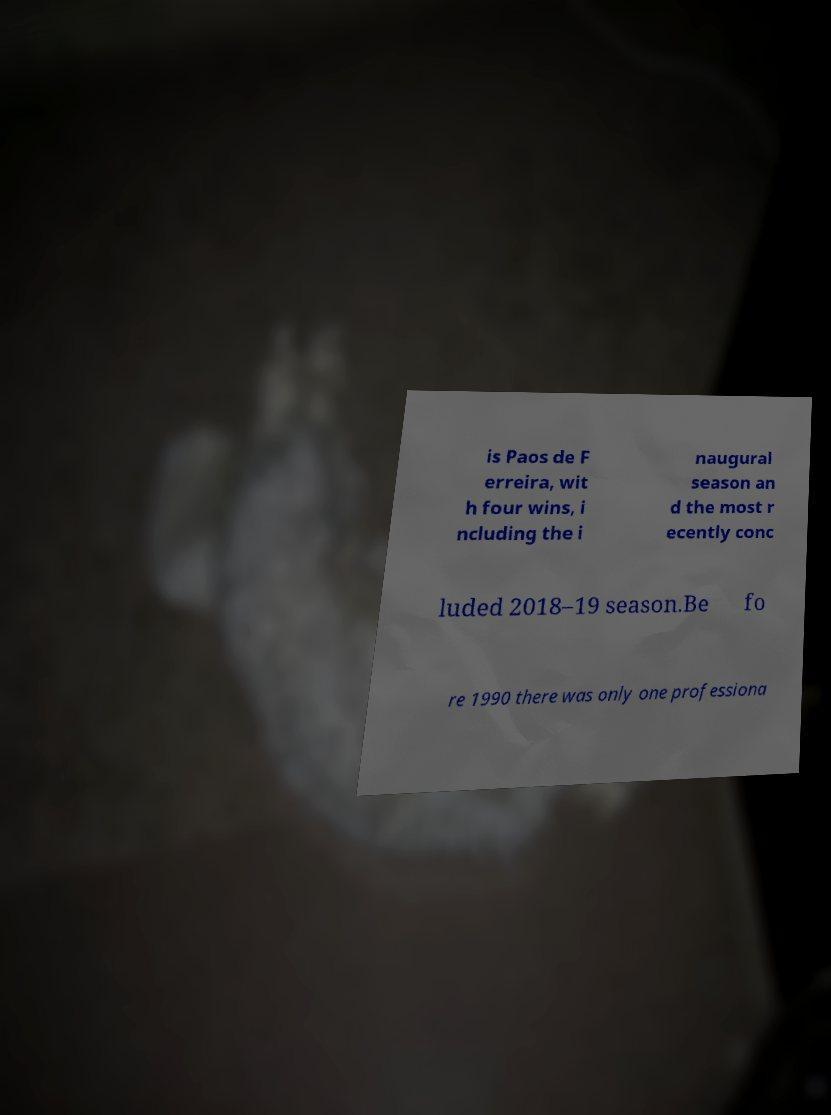Could you assist in decoding the text presented in this image and type it out clearly? is Paos de F erreira, wit h four wins, i ncluding the i naugural season an d the most r ecently conc luded 2018–19 season.Be fo re 1990 there was only one professiona 